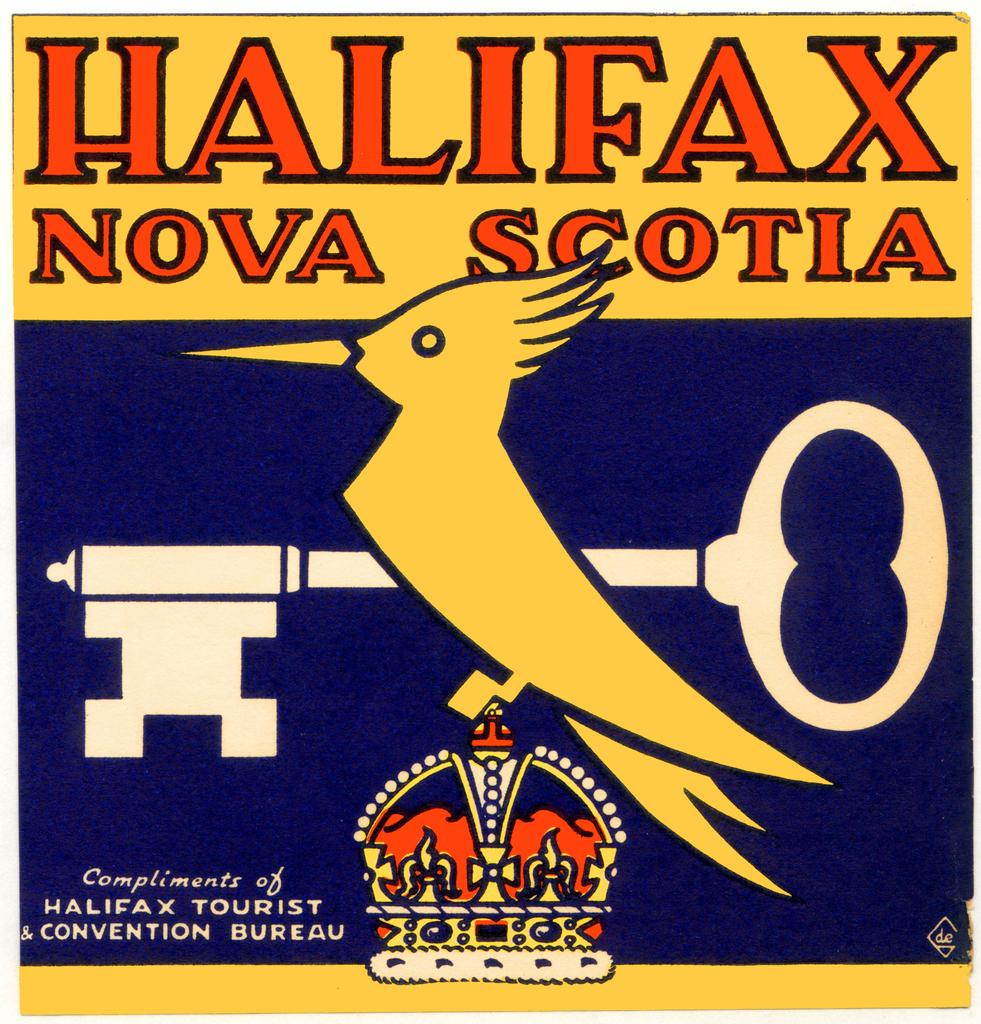What type of visual is the image? The image is a poster. What is the main subject of the poster? There is a picture of a bird on the poster. What other objects are depicted on the poster? There is a key and a crown present on the poster. Is there any text on the poster? Yes, there is text written on the poster. What type of team is shown playing with a jar in the image? There is no team or jar present in the image; it features a bird, a key, and a crown on a poster with text. 